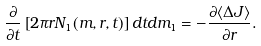Convert formula to latex. <formula><loc_0><loc_0><loc_500><loc_500>\frac { \partial } { \partial t } \left [ 2 \pi r N _ { 1 } ( m , r , t ) \right ] d t d m _ { 1 } = - \frac { \partial \langle \Delta J \rangle } { \partial r } .</formula> 